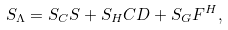<formula> <loc_0><loc_0><loc_500><loc_500>S _ { \Lambda } = S _ { C } S + S _ { H } C D + S _ { G } F ^ { H } ,</formula> 